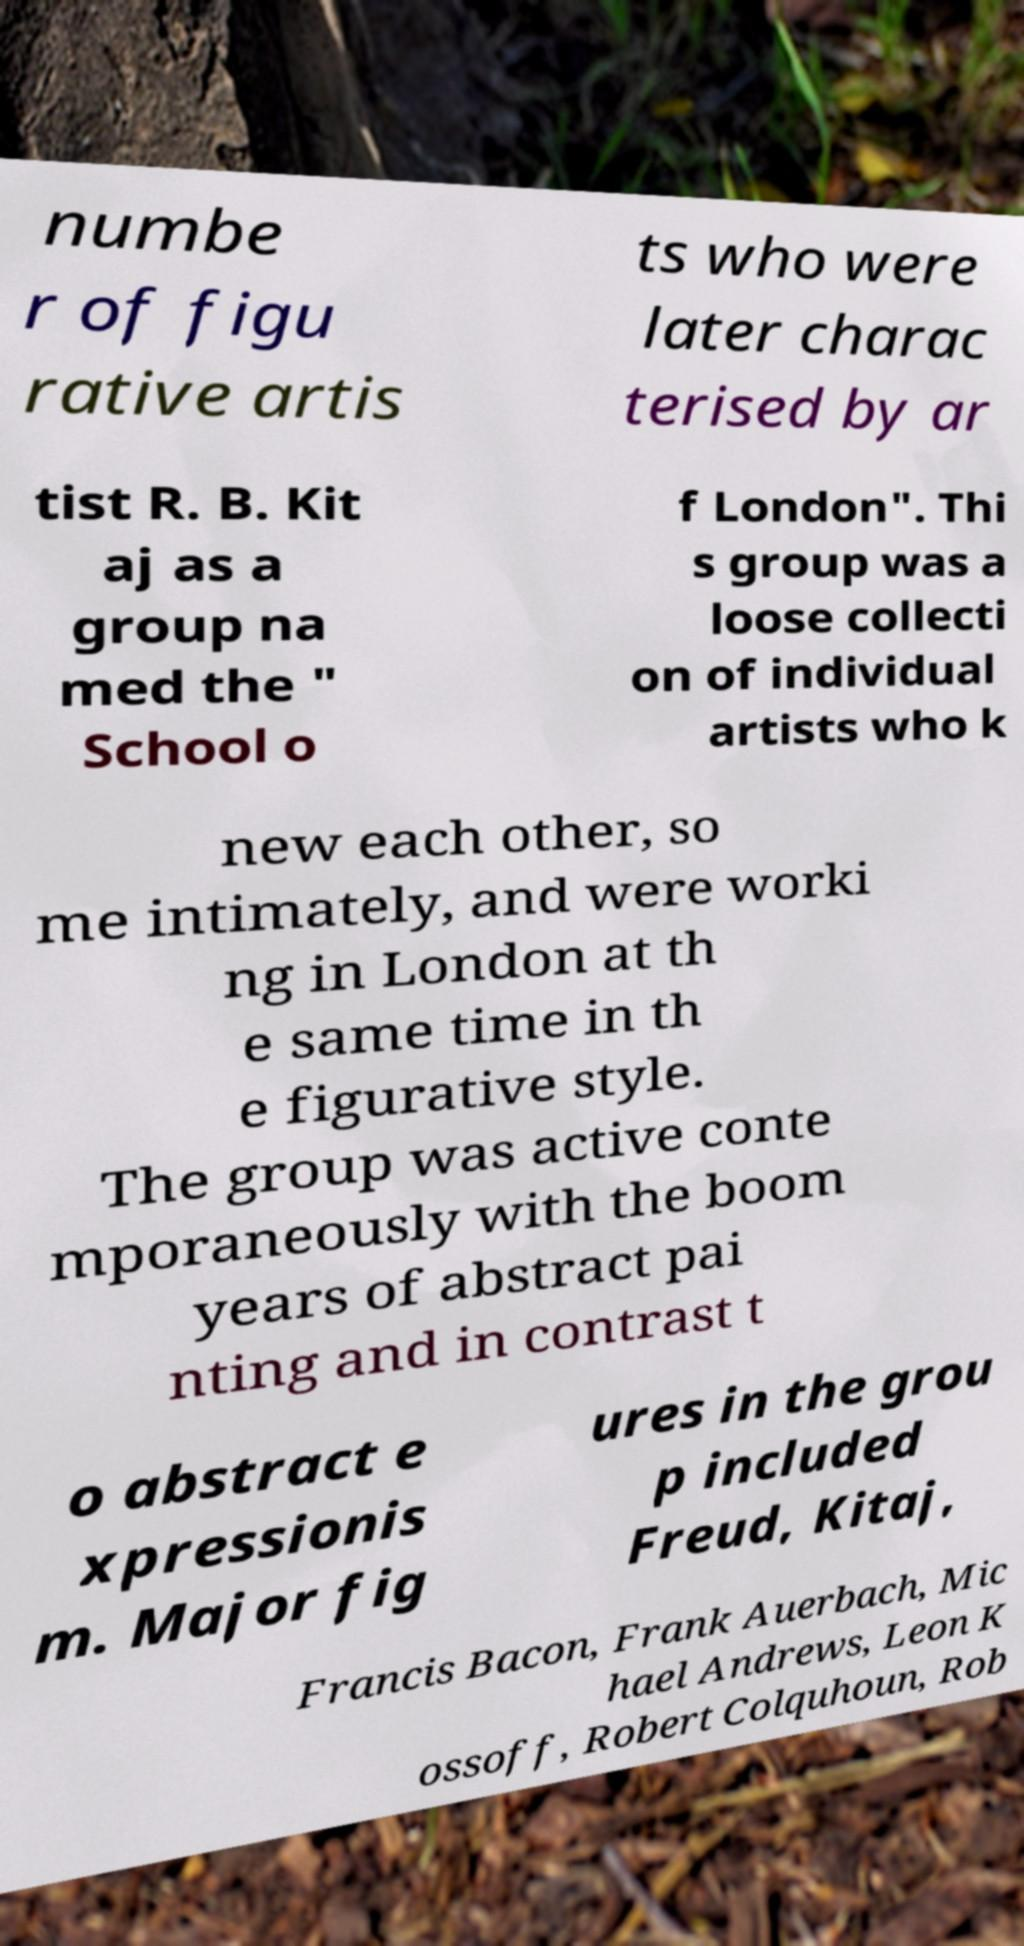Could you extract and type out the text from this image? numbe r of figu rative artis ts who were later charac terised by ar tist R. B. Kit aj as a group na med the " School o f London". Thi s group was a loose collecti on of individual artists who k new each other, so me intimately, and were worki ng in London at th e same time in th e figurative style. The group was active conte mporaneously with the boom years of abstract pai nting and in contrast t o abstract e xpressionis m. Major fig ures in the grou p included Freud, Kitaj, Francis Bacon, Frank Auerbach, Mic hael Andrews, Leon K ossoff, Robert Colquhoun, Rob 